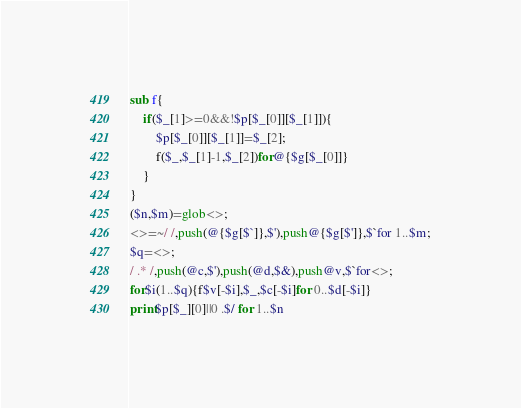Convert code to text. <code><loc_0><loc_0><loc_500><loc_500><_Perl_>sub f{
	if($_[1]>=0&&!$p[$_[0]][$_[1]]){
		$p[$_[0]][$_[1]]=$_[2];
		f($_,$_[1]-1,$_[2])for@{$g[$_[0]]}
	}
}
($n,$m)=glob<>;
<>=~/ /,push(@{$g[$`]},$'),push@{$g[$']},$`for 1..$m;
$q=<>;
/ .* /,push(@c,$'),push(@d,$&),push@v,$`for<>;
for$i(1..$q){f$v[-$i],$_,$c[-$i]for 0..$d[-$i]}
print$p[$_][0]||0 .$/ for 1..$n</code> 